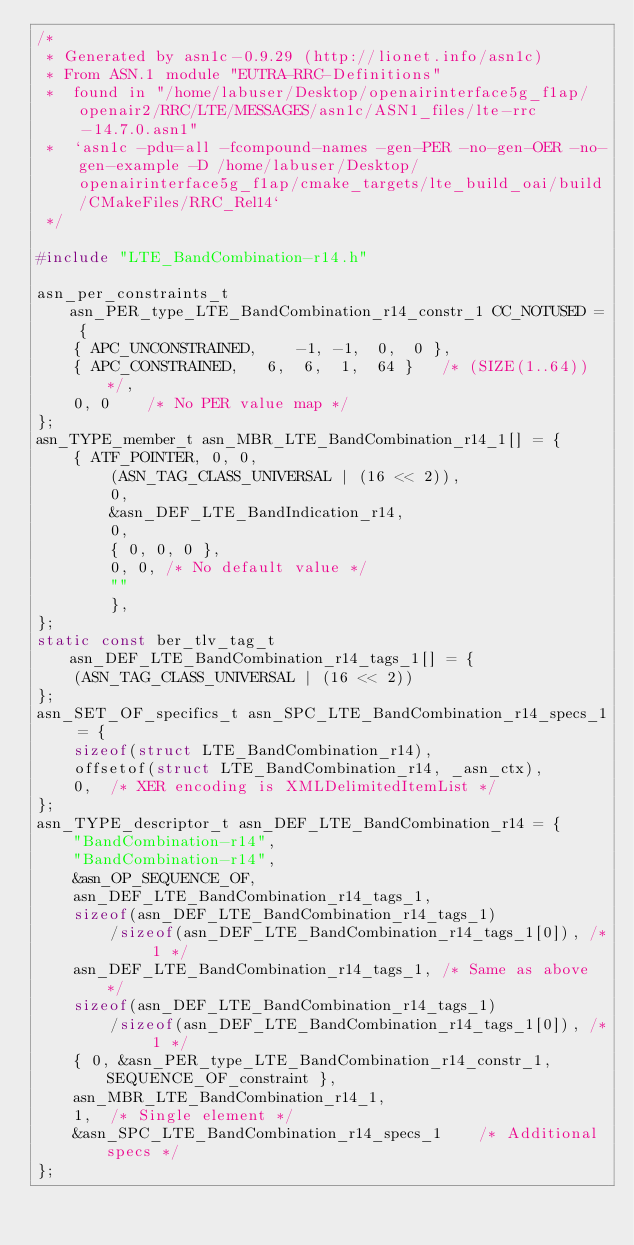<code> <loc_0><loc_0><loc_500><loc_500><_C_>/*
 * Generated by asn1c-0.9.29 (http://lionet.info/asn1c)
 * From ASN.1 module "EUTRA-RRC-Definitions"
 * 	found in "/home/labuser/Desktop/openairinterface5g_f1ap/openair2/RRC/LTE/MESSAGES/asn1c/ASN1_files/lte-rrc-14.7.0.asn1"
 * 	`asn1c -pdu=all -fcompound-names -gen-PER -no-gen-OER -no-gen-example -D /home/labuser/Desktop/openairinterface5g_f1ap/cmake_targets/lte_build_oai/build/CMakeFiles/RRC_Rel14`
 */

#include "LTE_BandCombination-r14.h"

asn_per_constraints_t asn_PER_type_LTE_BandCombination_r14_constr_1 CC_NOTUSED = {
	{ APC_UNCONSTRAINED,	-1, -1,  0,  0 },
	{ APC_CONSTRAINED,	 6,  6,  1,  64 }	/* (SIZE(1..64)) */,
	0, 0	/* No PER value map */
};
asn_TYPE_member_t asn_MBR_LTE_BandCombination_r14_1[] = {
	{ ATF_POINTER, 0, 0,
		(ASN_TAG_CLASS_UNIVERSAL | (16 << 2)),
		0,
		&asn_DEF_LTE_BandIndication_r14,
		0,
		{ 0, 0, 0 },
		0, 0, /* No default value */
		""
		},
};
static const ber_tlv_tag_t asn_DEF_LTE_BandCombination_r14_tags_1[] = {
	(ASN_TAG_CLASS_UNIVERSAL | (16 << 2))
};
asn_SET_OF_specifics_t asn_SPC_LTE_BandCombination_r14_specs_1 = {
	sizeof(struct LTE_BandCombination_r14),
	offsetof(struct LTE_BandCombination_r14, _asn_ctx),
	0,	/* XER encoding is XMLDelimitedItemList */
};
asn_TYPE_descriptor_t asn_DEF_LTE_BandCombination_r14 = {
	"BandCombination-r14",
	"BandCombination-r14",
	&asn_OP_SEQUENCE_OF,
	asn_DEF_LTE_BandCombination_r14_tags_1,
	sizeof(asn_DEF_LTE_BandCombination_r14_tags_1)
		/sizeof(asn_DEF_LTE_BandCombination_r14_tags_1[0]), /* 1 */
	asn_DEF_LTE_BandCombination_r14_tags_1,	/* Same as above */
	sizeof(asn_DEF_LTE_BandCombination_r14_tags_1)
		/sizeof(asn_DEF_LTE_BandCombination_r14_tags_1[0]), /* 1 */
	{ 0, &asn_PER_type_LTE_BandCombination_r14_constr_1, SEQUENCE_OF_constraint },
	asn_MBR_LTE_BandCombination_r14_1,
	1,	/* Single element */
	&asn_SPC_LTE_BandCombination_r14_specs_1	/* Additional specs */
};

</code> 